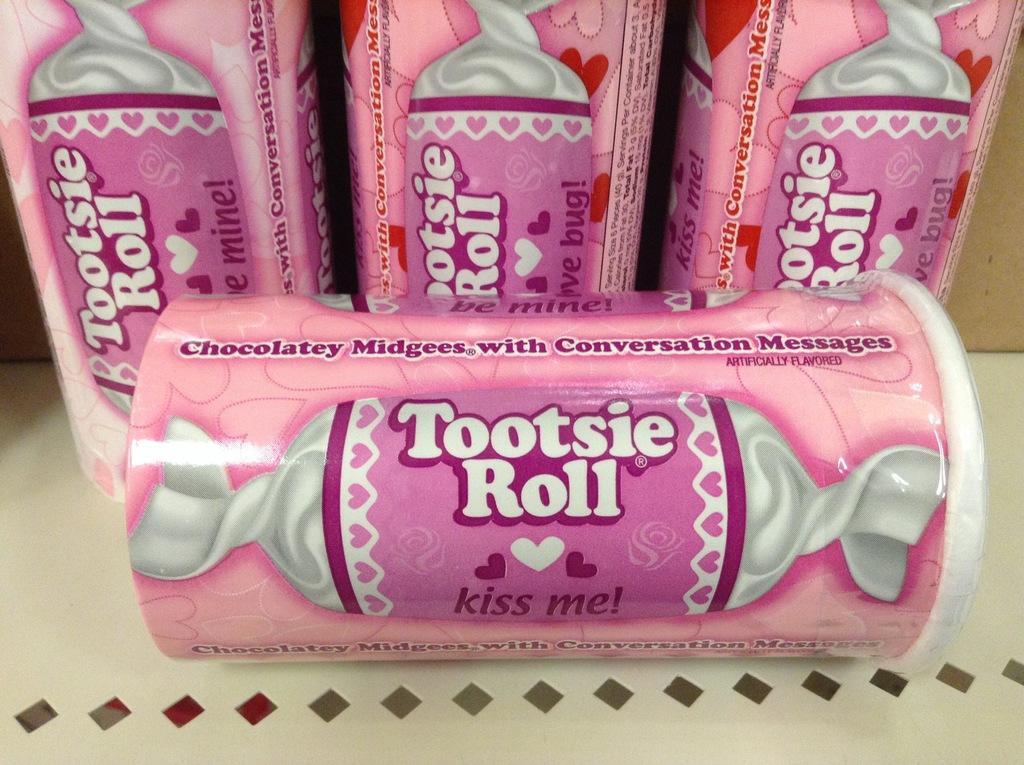How would you summarize this image in a sentence or two? In this image we can see chocolate boxes on the surface. 